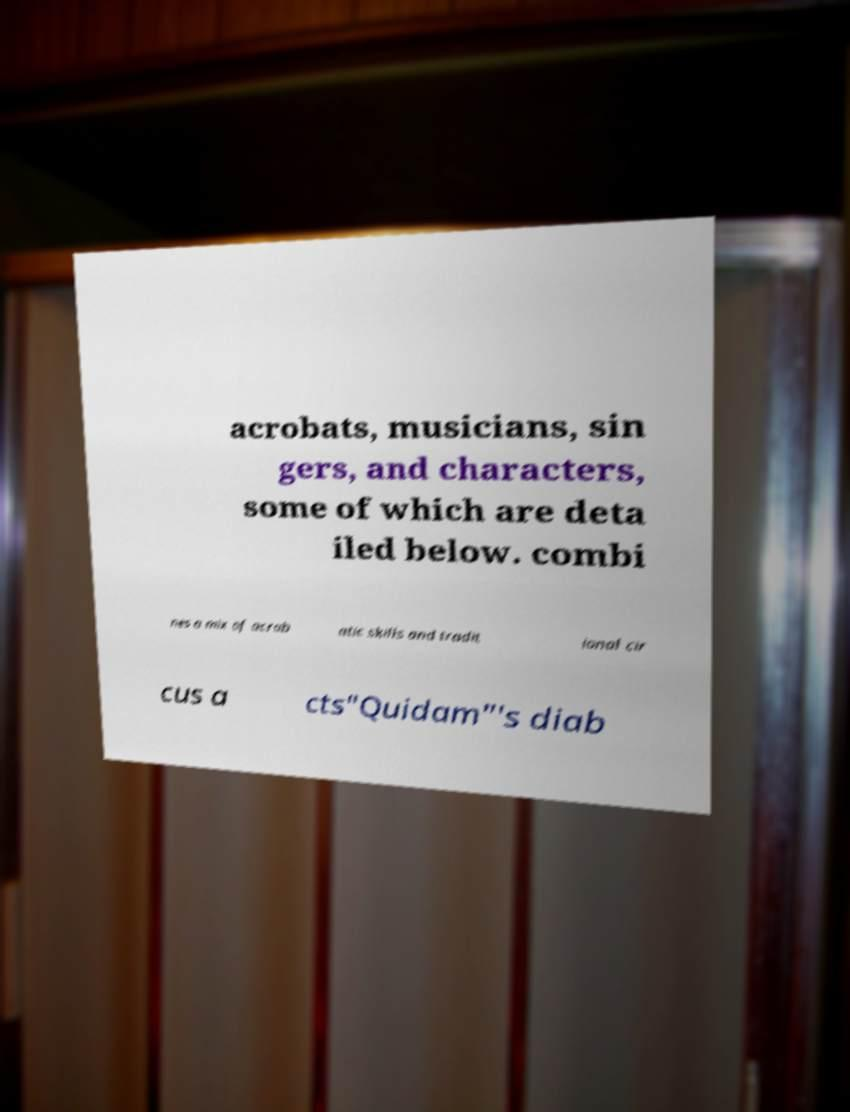Could you assist in decoding the text presented in this image and type it out clearly? acrobats, musicians, sin gers, and characters, some of which are deta iled below. combi nes a mix of acrob atic skills and tradit ional cir cus a cts"Quidam"'s diab 